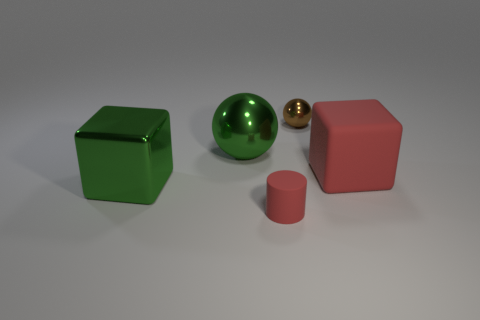How many other objects are the same color as the big matte thing?
Keep it short and to the point. 1. Is there any other thing that is the same shape as the small matte thing?
Provide a short and direct response. No. Does the block that is to the right of the green metal block have the same size as the large metallic cube?
Ensure brevity in your answer.  Yes. Is there a big matte block that is right of the large green object that is behind the large metal cube?
Keep it short and to the point. Yes. What is the small red object made of?
Ensure brevity in your answer.  Rubber. Are there any big green things behind the large matte object?
Offer a very short reply. Yes. There is another shiny thing that is the same shape as the tiny brown metal thing; what is its size?
Offer a terse response. Large. Are there an equal number of matte things that are left of the big green metallic cube and big blocks that are to the right of the brown sphere?
Your answer should be very brief. No. How many big cyan rubber cylinders are there?
Provide a succinct answer. 0. Are there more green objects that are behind the large metallic block than tiny purple things?
Make the answer very short. Yes. 